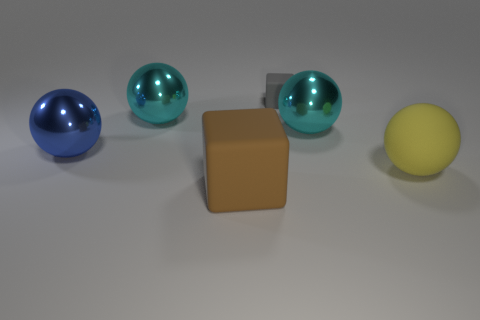There is a metal sphere that is to the right of the big rubber block; does it have the same color as the large matte cube?
Ensure brevity in your answer.  No. Is there a large matte block of the same color as the matte sphere?
Keep it short and to the point. No. How many yellow spheres are behind the brown rubber block?
Your response must be concise. 1. What number of other things are there of the same size as the yellow rubber thing?
Provide a short and direct response. 4. Does the large sphere in front of the blue shiny thing have the same material as the cube in front of the large blue metallic object?
Provide a succinct answer. Yes. What is the color of the matte object that is the same size as the yellow sphere?
Provide a succinct answer. Brown. Are there any other things that have the same color as the big rubber ball?
Provide a succinct answer. No. There is a cyan sphere on the left side of the cube in front of the matte block behind the big yellow rubber ball; what size is it?
Offer a very short reply. Large. There is a metal ball that is both left of the small thing and to the right of the blue sphere; what color is it?
Provide a short and direct response. Cyan. There is a brown rubber object in front of the gray rubber block; how big is it?
Your response must be concise. Large. 